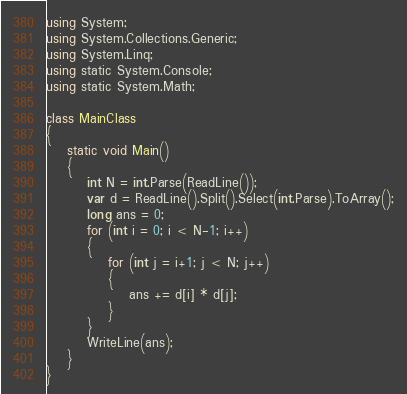Convert code to text. <code><loc_0><loc_0><loc_500><loc_500><_C#_>using System;
using System.Collections.Generic;
using System.Linq;
using static System.Console;
using static System.Math;

class MainClass
{
    static void Main()
    {
        int N = int.Parse(ReadLine());
        var d = ReadLine().Split().Select(int.Parse).ToArray();
        long ans = 0;
        for (int i = 0; i < N-1; i++)
        {
            for (int j = i+1; j < N; j++)
            {
                ans += d[i] * d[j];
            }
        }
        WriteLine(ans);
    }
}
</code> 